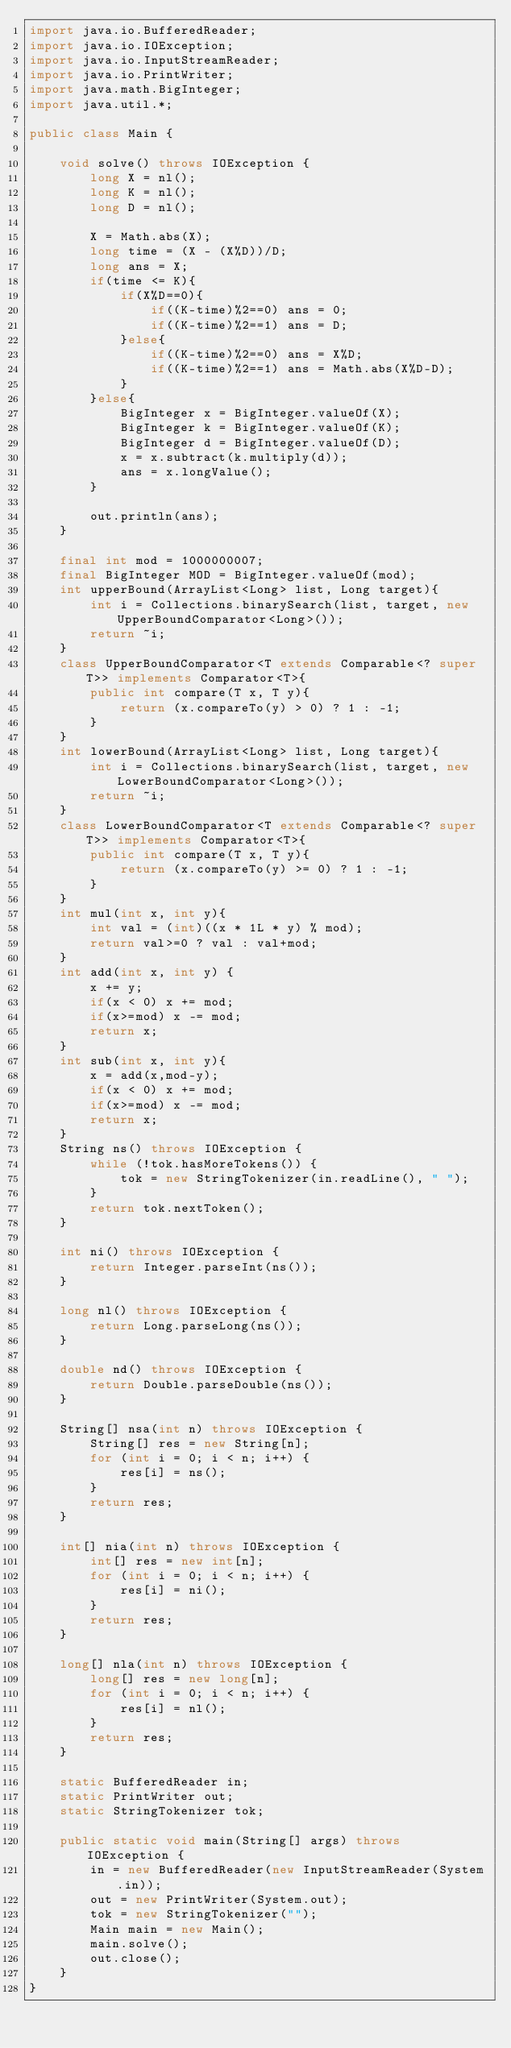<code> <loc_0><loc_0><loc_500><loc_500><_Java_>import java.io.BufferedReader;
import java.io.IOException;
import java.io.InputStreamReader;
import java.io.PrintWriter;
import java.math.BigInteger;
import java.util.*;
 
public class Main {
 
    void solve() throws IOException {
        long X = nl();
        long K = nl();
        long D = nl();

        X = Math.abs(X);
        long time = (X - (X%D))/D;
        long ans = X;
        if(time <= K){
            if(X%D==0){
                if((K-time)%2==0) ans = 0;
                if((K-time)%2==1) ans = D; 
            }else{
                if((K-time)%2==0) ans = X%D;
                if((K-time)%2==1) ans = Math.abs(X%D-D);
            }
        }else{
            BigInteger x = BigInteger.valueOf(X);
            BigInteger k = BigInteger.valueOf(K);
            BigInteger d = BigInteger.valueOf(D);
            x = x.subtract(k.multiply(d));
            ans = x.longValue();
        }
 
        out.println(ans);
    }

    final int mod = 1000000007;
    final BigInteger MOD = BigInteger.valueOf(mod);
    int upperBound(ArrayList<Long> list, Long target){
        int i = Collections.binarySearch(list, target, new UpperBoundComparator<Long>());
        return ~i;
    }
    class UpperBoundComparator<T extends Comparable<? super T>> implements Comparator<T>{
        public int compare(T x, T y){
            return (x.compareTo(y) > 0) ? 1 : -1;
        }
    }
    int lowerBound(ArrayList<Long> list, Long target){
        int i = Collections.binarySearch(list, target, new LowerBoundComparator<Long>());
        return ~i;
    }
    class LowerBoundComparator<T extends Comparable<? super T>> implements Comparator<T>{
        public int compare(T x, T y){
            return (x.compareTo(y) >= 0) ? 1 : -1;
        }
    }
    int mul(int x, int y){
        int val = (int)((x * 1L * y) % mod);
        return val>=0 ? val : val+mod;
    }
    int add(int x, int y) {
        x += y;
        if(x < 0) x += mod;
        if(x>=mod) x -= mod;
        return x;
    }
    int sub(int x, int y){
        x = add(x,mod-y);
        if(x < 0) x += mod;
        if(x>=mod) x -= mod;
        return x;
    }
    String ns() throws IOException {
        while (!tok.hasMoreTokens()) {
            tok = new StringTokenizer(in.readLine(), " ");
        }
        return tok.nextToken();
    }
 
    int ni() throws IOException {
        return Integer.parseInt(ns());
    }
 
    long nl() throws IOException {
        return Long.parseLong(ns());
    }
 
    double nd() throws IOException {
        return Double.parseDouble(ns());
    }
 
    String[] nsa(int n) throws IOException {
        String[] res = new String[n];
        for (int i = 0; i < n; i++) {
            res[i] = ns();
        }
        return res;
    }
 
    int[] nia(int n) throws IOException {
        int[] res = new int[n];
        for (int i = 0; i < n; i++) {
            res[i] = ni();
        }
        return res;
    }
 
    long[] nla(int n) throws IOException {
        long[] res = new long[n];
        for (int i = 0; i < n; i++) {
            res[i] = nl();
        }
        return res;
    }
 
    static BufferedReader in;
    static PrintWriter out;
    static StringTokenizer tok;
 
    public static void main(String[] args) throws IOException {
        in = new BufferedReader(new InputStreamReader(System.in));
        out = new PrintWriter(System.out);
        tok = new StringTokenizer("");
        Main main = new Main();
        main.solve();
        out.close();
    }
}</code> 